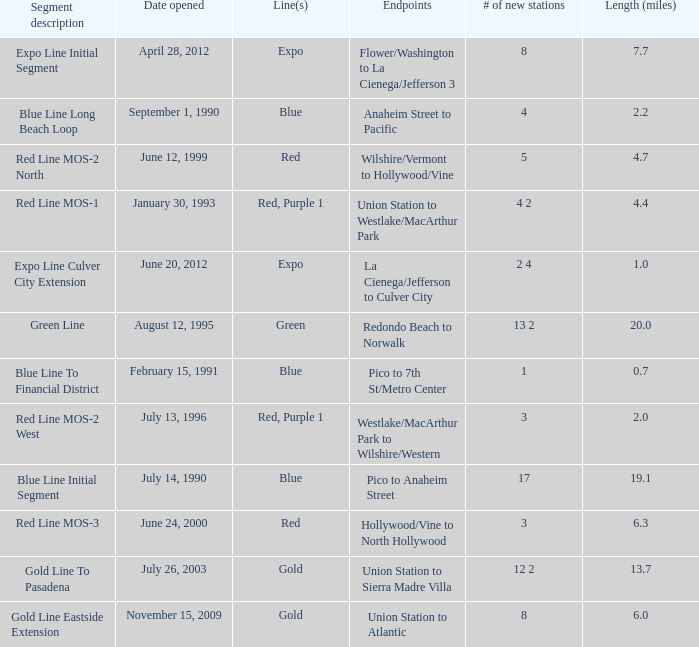What is the length  (miles) when pico to 7th st/metro center are the endpoints? 0.7. 